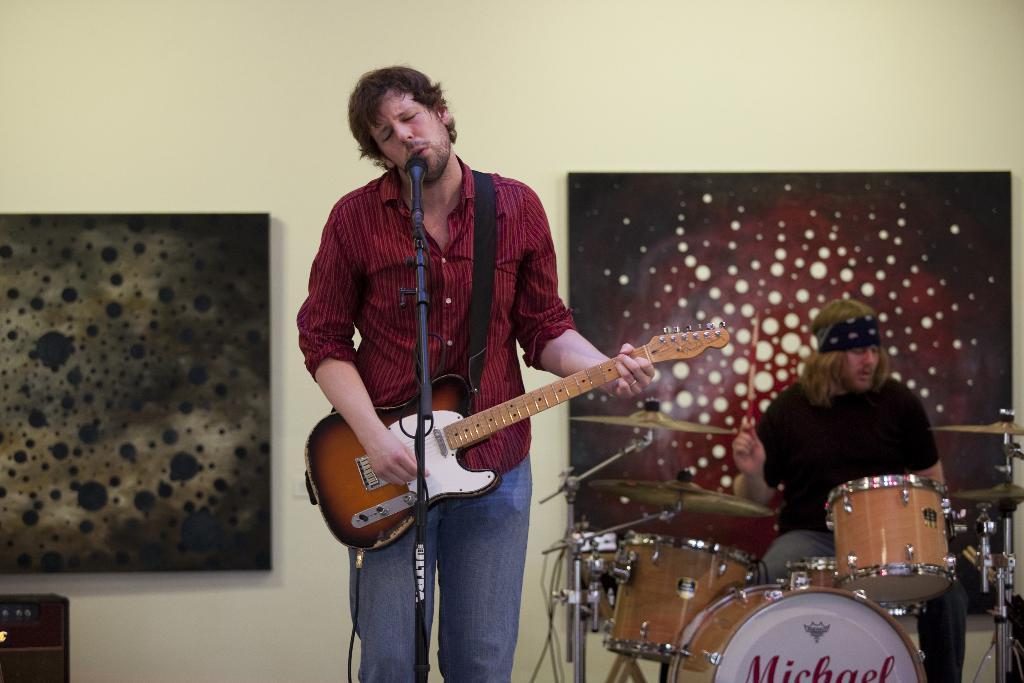How would you summarize this image in a sentence or two? a person is standing playing guitar and singing in front of a microphone. behind him at the left , a person is playing drums. at the back on the wall 2 frames are present. 